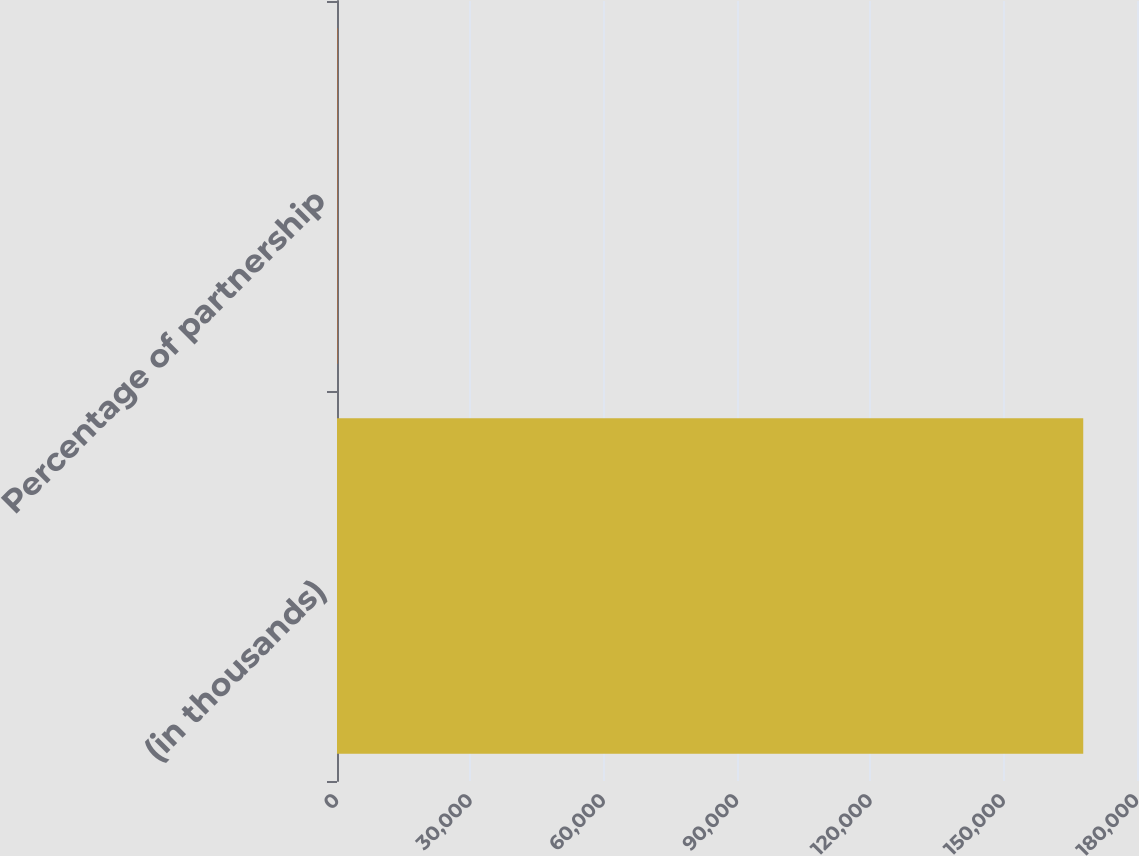<chart> <loc_0><loc_0><loc_500><loc_500><bar_chart><fcel>(in thousands)<fcel>Percentage of partnership<nl><fcel>167904<fcel>99.8<nl></chart> 